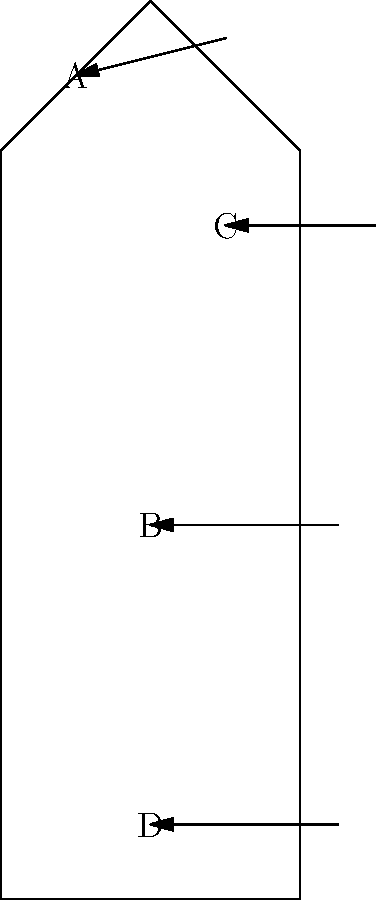As a paramedic, you're assessing a patient with a suspected fracture. Identify the bone labeled 'C' in the skeletal diagram. To identify the bone labeled 'C' in the skeletal diagram, let's follow these steps:

1. Observe the overall structure of the skeleton in the diagram. It represents a simplified human body.

2. Locate the label 'C' on the diagram. It's pointing to a bone in the upper part of the body.

3. Analyze the position of the bone:
   - It's located in the upper region of the torso.
   - It's positioned horizontally, connecting the central part of the body to the side.

4. Consider the anatomical knowledge relevant to a paramedic:
   - The bone in this location that runs horizontally from the center to the side of the upper body is the clavicle, also known as the collarbone.

5. The clavicle is an important bone for paramedics to be familiar with because:
   - It's commonly fractured in falls or direct impacts to the shoulder.
   - It's relatively superficial, making fractures often visible or palpable.
   - Injuries to this area can potentially compromise nearby vital structures.

Therefore, based on its position and anatomical knowledge, the bone labeled 'C' is the clavicle.
Answer: Clavicle (collarbone) 